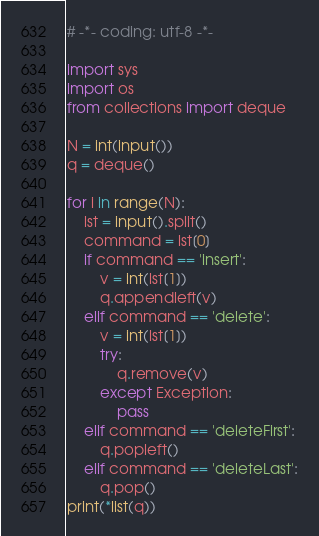<code> <loc_0><loc_0><loc_500><loc_500><_Python_># -*- coding: utf-8 -*-

import sys
import os
from collections import deque

N = int(input())
q = deque()

for i in range(N):
    lst = input().split()
    command = lst[0]
    if command == 'insert':
        v = int(lst[1])
        q.appendleft(v)
    elif command == 'delete':
        v = int(lst[1])
        try:
            q.remove(v)
        except Exception:
            pass
    elif command == 'deleteFirst':
        q.popleft()
    elif command == 'deleteLast':
        q.pop()
print(*list(q))</code> 